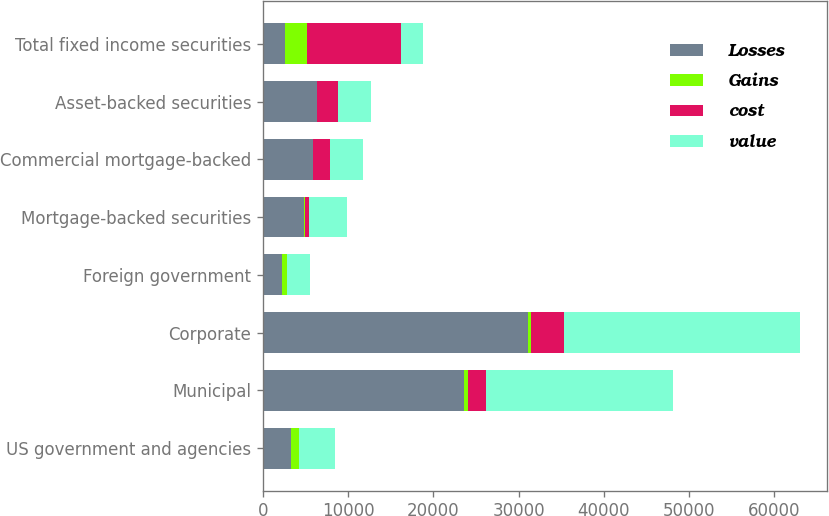Convert chart to OTSL. <chart><loc_0><loc_0><loc_500><loc_500><stacked_bar_chart><ecel><fcel>US government and agencies<fcel>Municipal<fcel>Corporate<fcel>Foreign government<fcel>Mortgage-backed securities<fcel>Commercial mortgage-backed<fcel>Asset-backed securities<fcel>Total fixed income securities<nl><fcel>Losses<fcel>3272<fcel>23565<fcel>31040<fcel>2206<fcel>4826<fcel>5840<fcel>6319<fcel>2610<nl><fcel>Gains<fcel>963<fcel>467<fcel>463<fcel>544<fcel>85<fcel>10<fcel>13<fcel>2545<nl><fcel>cost<fcel>1<fcel>2184<fcel>3876<fcel>75<fcel>419<fcel>2004<fcel>2472<fcel>11041<nl><fcel>value<fcel>4234<fcel>21848<fcel>27627<fcel>2675<fcel>4492<fcel>3846<fcel>3860<fcel>2610<nl></chart> 